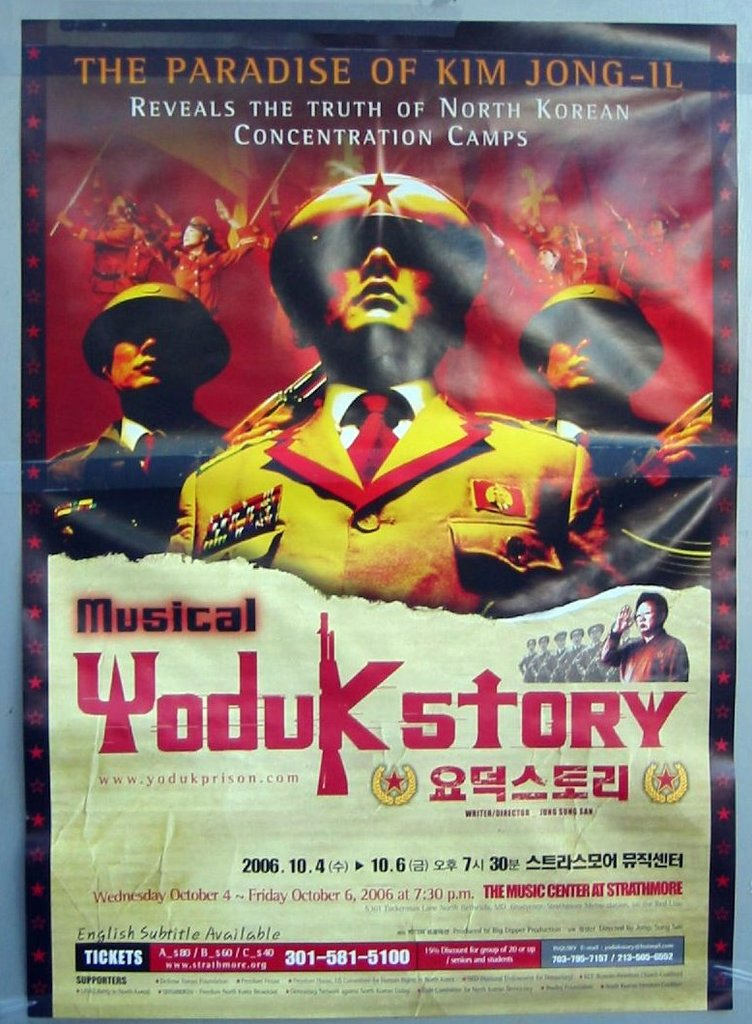Provide a one-sentence caption for the provided image. This is a promotional poster for 'Yoduk Story,' a musical that explores the harsh realities of North Korean concentration camps, with performances scheduled from October 4th to October 6th, 2006, featuring English subtitles at The Music Center at Strathmore. 